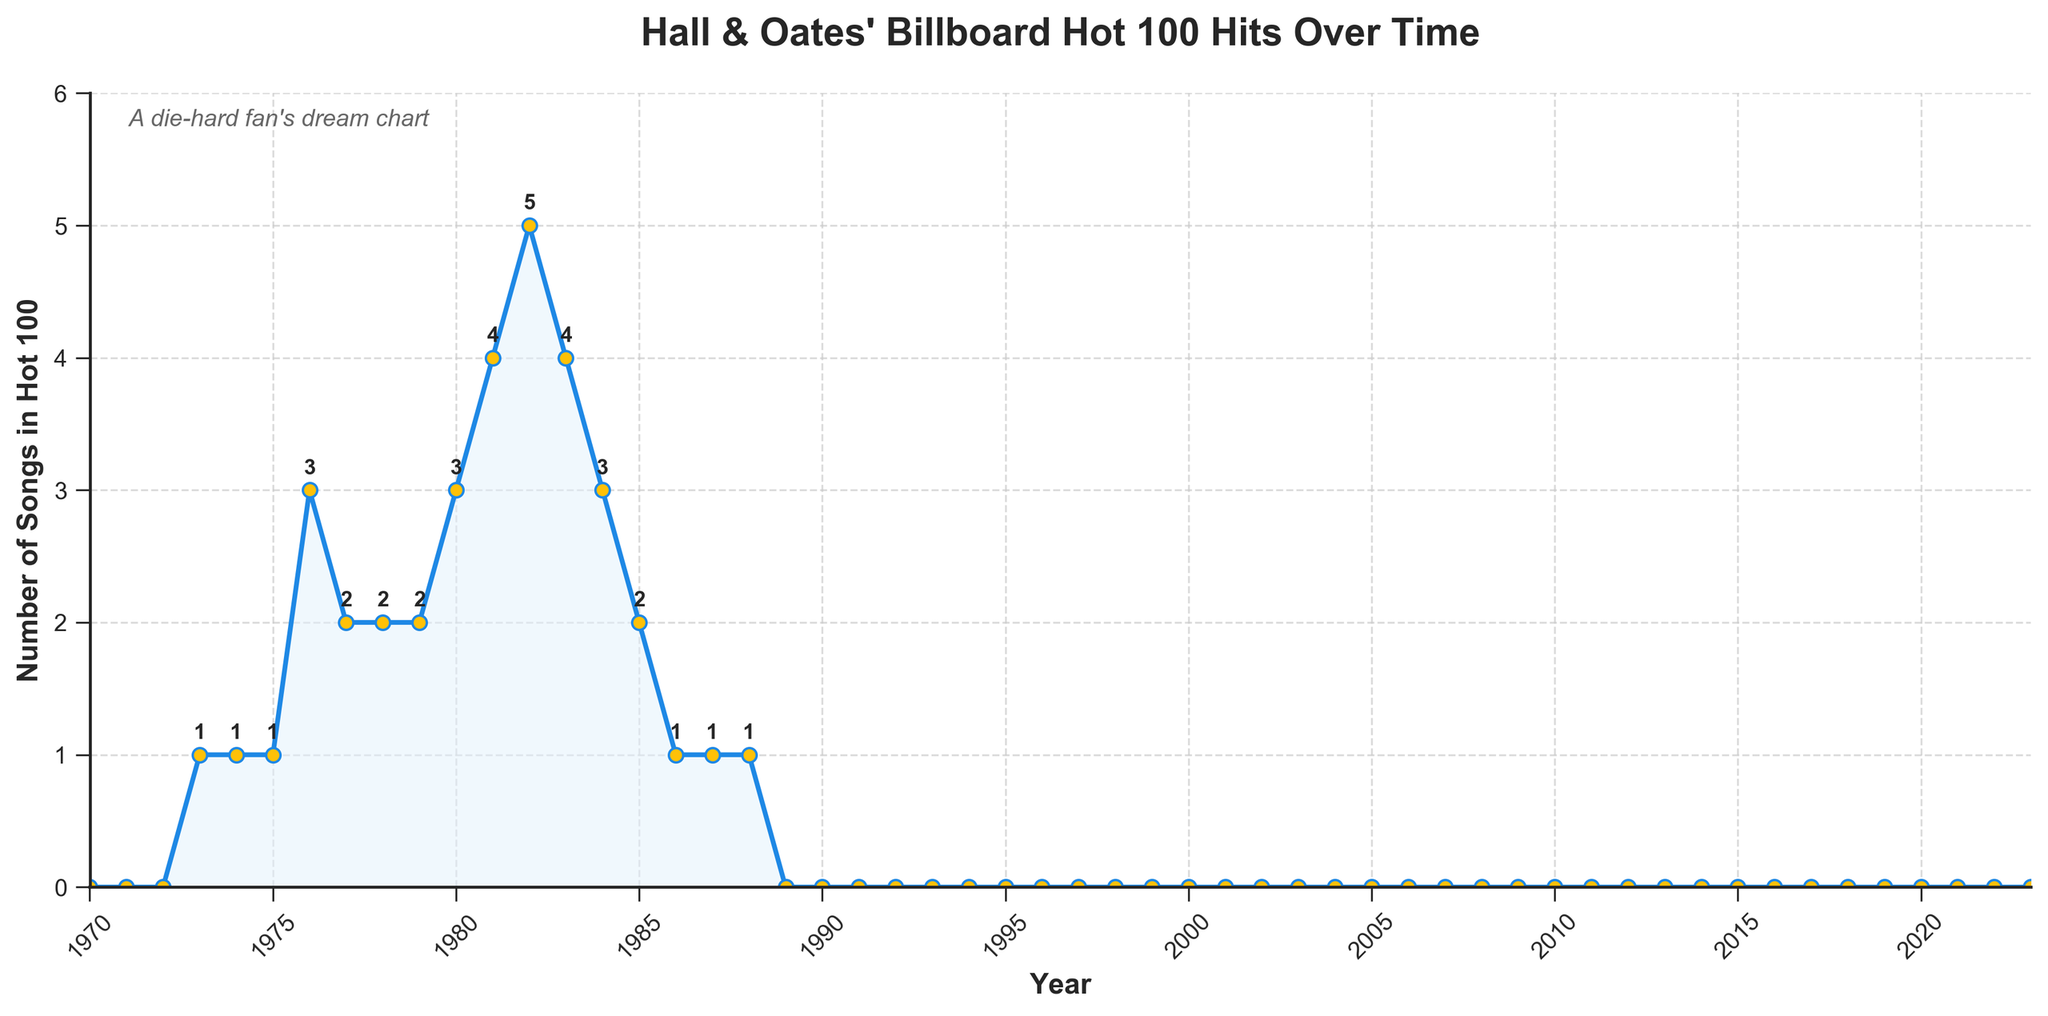What is the highest number of Hall & Oates songs that appeared in the Billboard Hot 100 in a single year? In the figure, identify the peak of the line chart and look at the y-axis value corresponding to it. The highest peak reaches 5 in 1982.
Answer: 5 In which year did Hall & Oates have the most songs on the Billboard Hot 100, and what was that number? Locate the highest point on the line chart and note the year on the x-axis where this peak occurs. The peak at 5 songs is in 1982.
Answer: 1982, 5 Between which years did Hall & Oates first manage to get and then lose the steady presence of songs in the Billboard Hot 100? Identify the first rise in the line chart and its endpoint. The first rise begins in 1973, with a steady presence until it drops after 1988.
Answer: 1973 to 1988 How many times did Hall & Oates have exactly 3 songs in the Billboard Hot 100 in a year? Look for the points on the line chart where the y-value is 3 and count them. The years 1976, 1980, and 1984 each have 3 songs.
Answer: 3 What is the average number of Hall & Oates songs on the Billboard Hot 100 during their most active period (1973 to 1988)? Identify the active period from 1973 to 1988, sum the total number of songs and divide by the number of years. Active years = 16, total songs = 33, average = 33/16.
Answer: 2.06 How many years did Hall & Oates have at least one song in the Billboard Hot 100? Count the number of years where the line chart is above zero. Such years are between 1973 and 1988.
Answer: 16 Compare the number of Hall & Oates songs in the Billboard Hot 100 between 1981 and 1983. Did they have more songs in 1982 than in any other year? Check the data points on the line chart for 1981, 1982, and 1983. In 1981, they had 4 songs, in 1982, 5 songs, and in 1983, 4 songs. 1982 had the most.
Answer: Yes In what year did Hall & Oates' presence in the Billboard Hot 100 begin to decline after their peak? Find the highest point in 1982 and observe the subsequent decrease. The decline starts in 1983.
Answer: 1983 What is the trend of Hall & Oates songs in the Billboard Hot 100 after 1988? Look at the chart line after 1988, which remains flat at 0.
Answer: No songs How many songs in total did Hall & Oates have on the Billboard Hot 100 between 1973 and 1988? Sum the number of songs for each year between 1973 and 1988. Sum = 1 + 1 + 1 + 3 + 2 + 2 + 2 + 3 + 4 + 5 + 4 + 3 + 2 + 1 + 1 + 1.
Answer: 33 